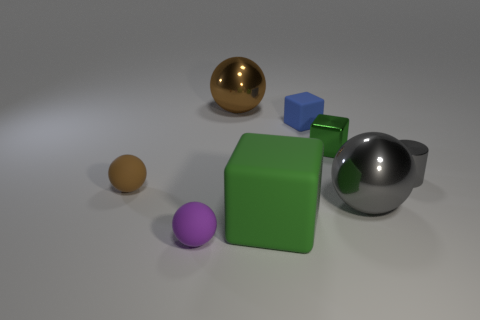Which objects in the image seem metallic, and how does their appearance differ from the others? In the image, the objects that appear metallic are the golden sphere and the dark grey sphere. Their shiny surface reflects light differently compared to the matte finish of the other objects, giving them a distinctive luster that indicates they might be made of metal. 